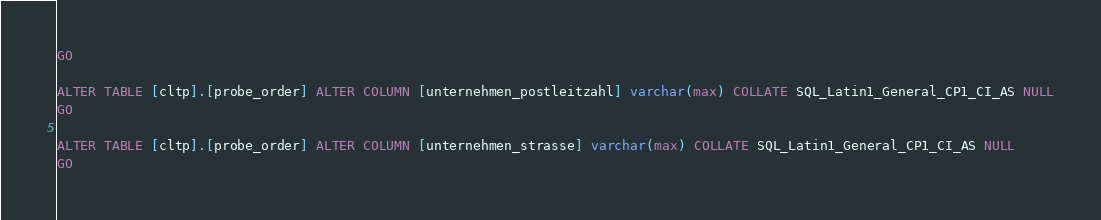<code> <loc_0><loc_0><loc_500><loc_500><_SQL_>GO

ALTER TABLE [cltp].[probe_order] ALTER COLUMN [unternehmen_postleitzahl] varchar(max) COLLATE SQL_Latin1_General_CP1_CI_AS NULL
GO

ALTER TABLE [cltp].[probe_order] ALTER COLUMN [unternehmen_strasse] varchar(max) COLLATE SQL_Latin1_General_CP1_CI_AS NULL
GO
</code> 